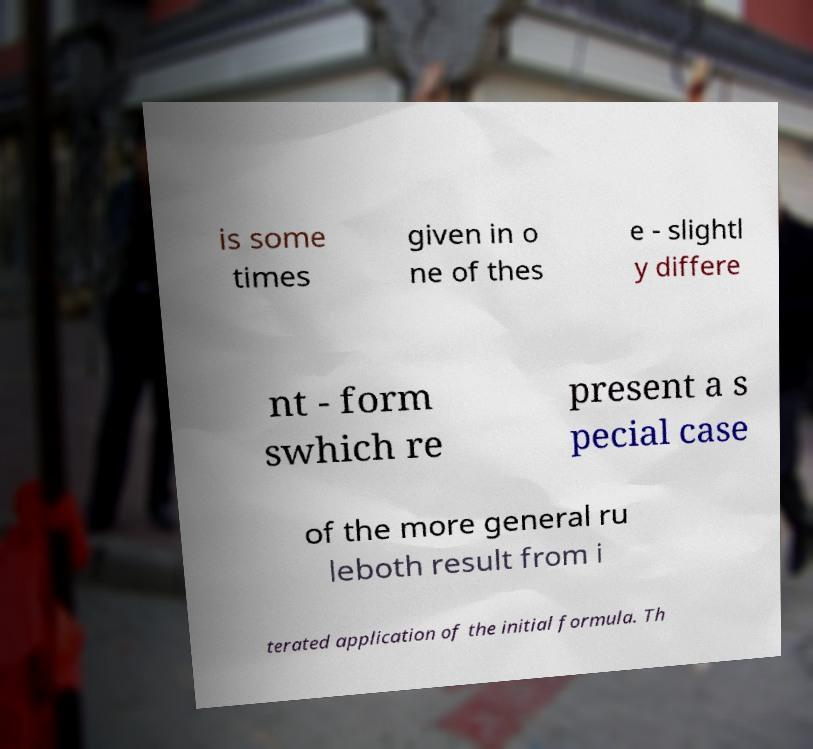Could you extract and type out the text from this image? is some times given in o ne of thes e - slightl y differe nt - form swhich re present a s pecial case of the more general ru leboth result from i terated application of the initial formula. Th 